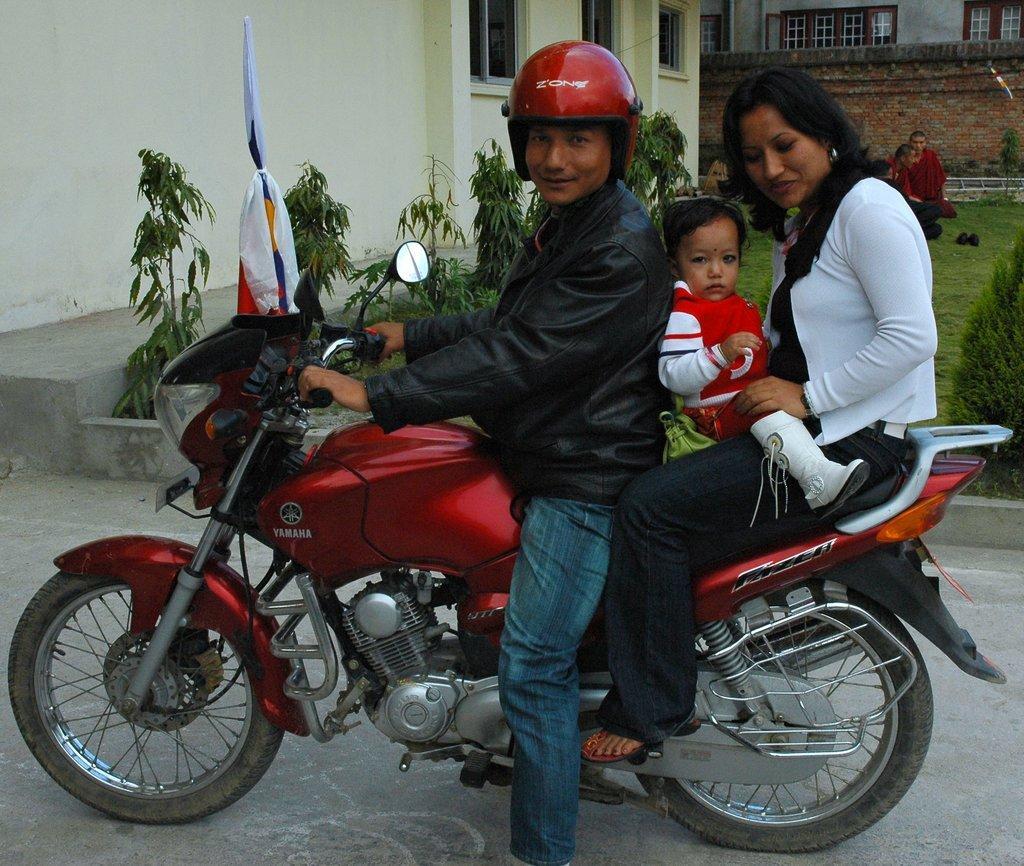How would you summarize this image in a sentence or two? Here we can see a couple of people sitting on a bike with a baby in between them and behind them we can see plants and a building 